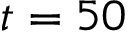Convert formula to latex. <formula><loc_0><loc_0><loc_500><loc_500>t = 5 0</formula> 